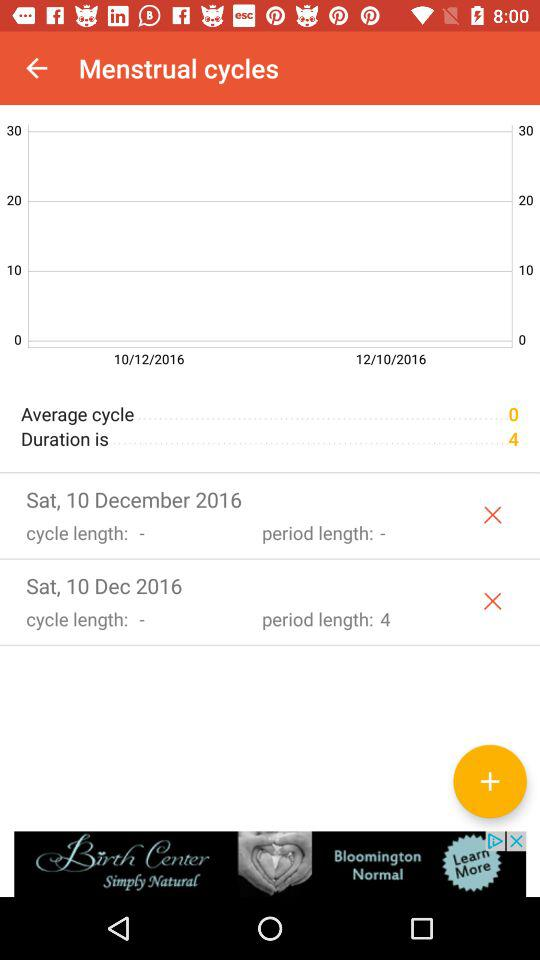How long is the period length? The period length is 4. 